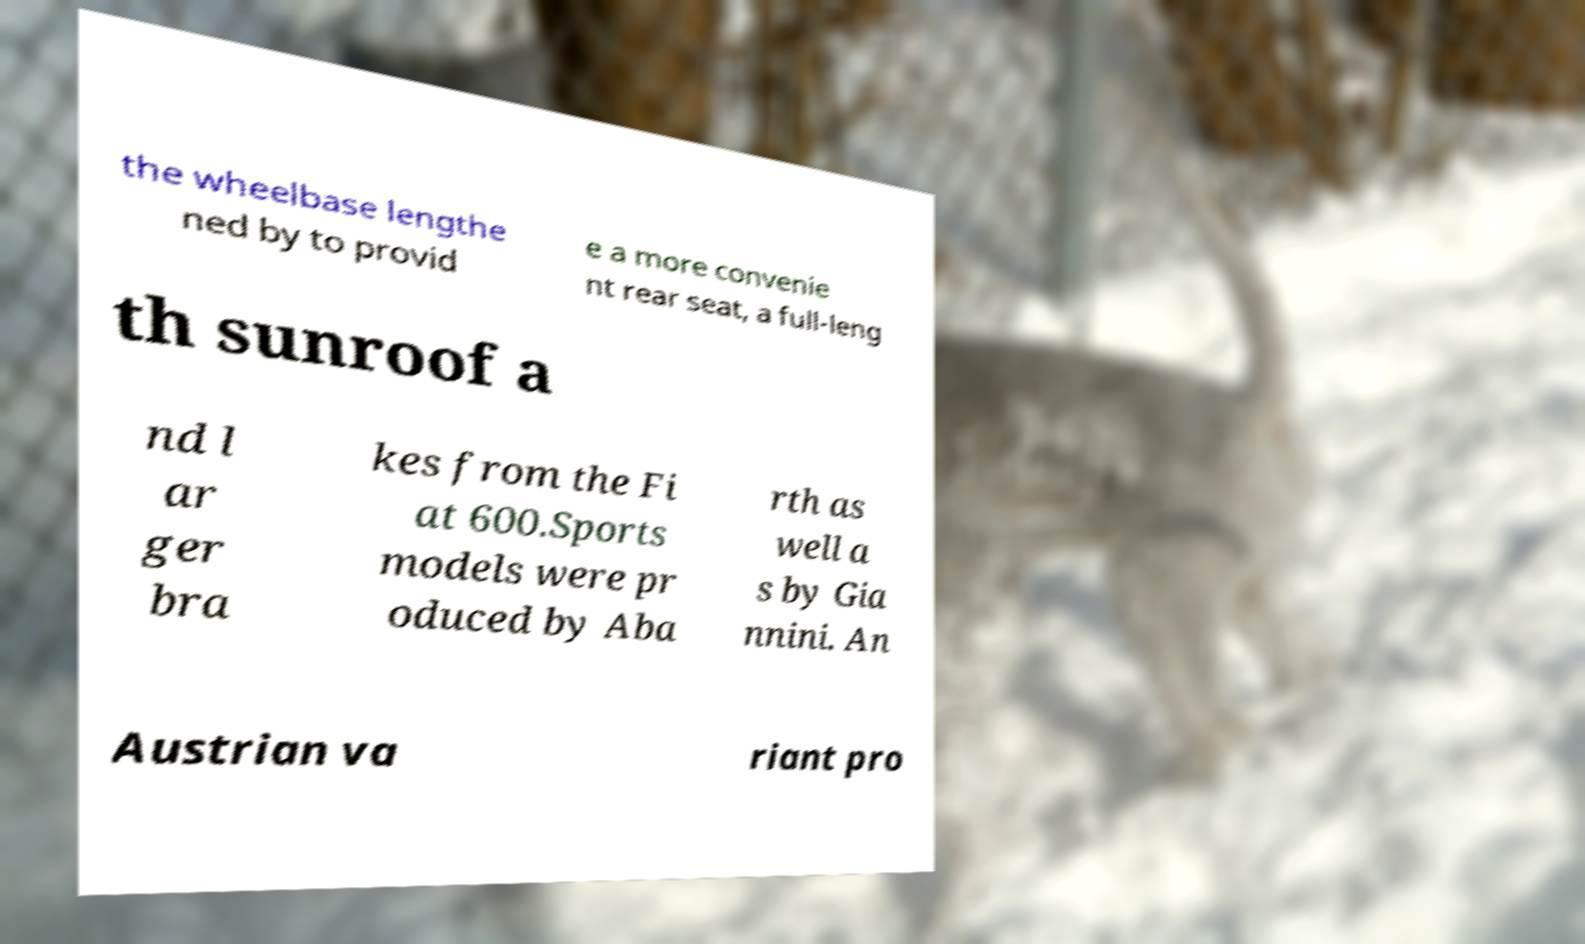For documentation purposes, I need the text within this image transcribed. Could you provide that? the wheelbase lengthe ned by to provid e a more convenie nt rear seat, a full-leng th sunroof a nd l ar ger bra kes from the Fi at 600.Sports models were pr oduced by Aba rth as well a s by Gia nnini. An Austrian va riant pro 